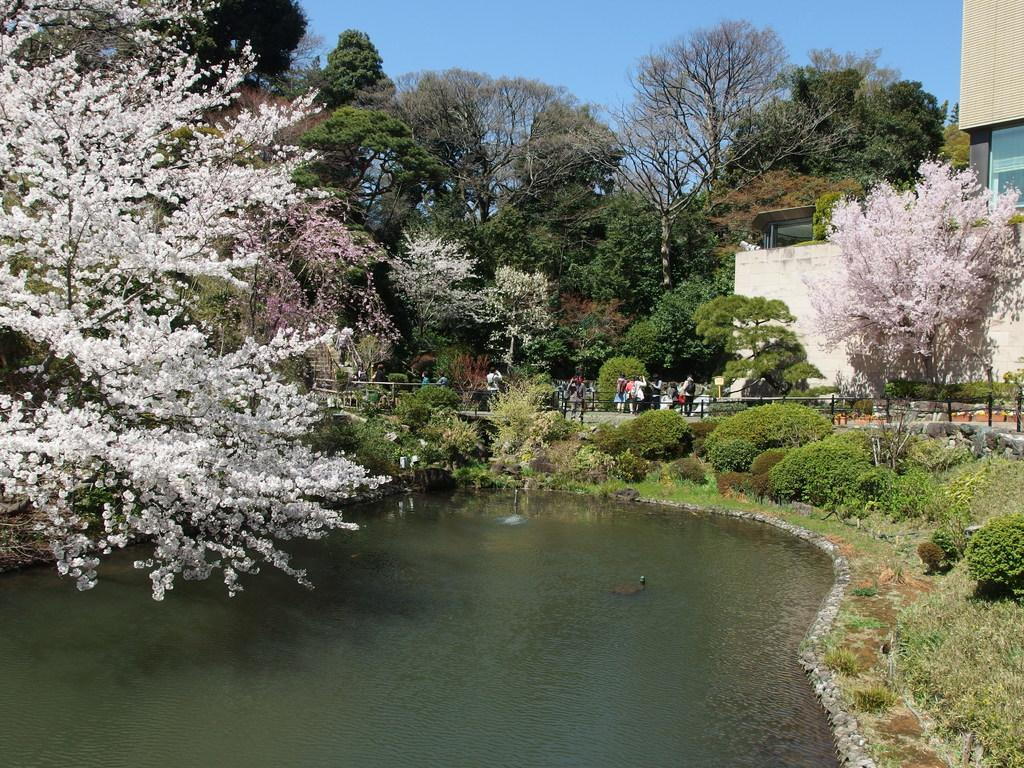What type of natural feature is present in the image? There is a lake in the image. What type of vegetation can be seen in the image? There are trees and plants in the image. What type of man-made structure is present in the image? There is a building in the image. What type of transportation infrastructure is present in the image? There is a road in the image. What are the people in the image doing? The people are standing on the road. Can you compare the size of the cannon to the trees in the image? There is no cannon present in the image, so it cannot be compared to the trees. How does the flight of the birds affect the water in the lake? There are no birds mentioned in the image, so their flight and its effect on the water cannot be determined. 